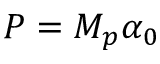Convert formula to latex. <formula><loc_0><loc_0><loc_500><loc_500>P = { { M } _ { p } } \alpha _ { 0 }</formula> 